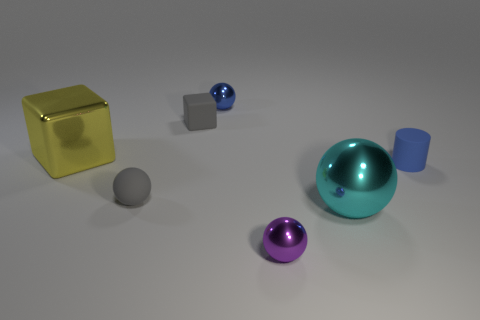Does the blue metallic thing have the same shape as the small purple object?
Offer a very short reply. Yes. How many matte objects are yellow blocks or tiny cyan cubes?
Keep it short and to the point. 0. What is the material of the thing that is the same color as the tiny cylinder?
Keep it short and to the point. Metal. Do the blue shiny thing and the yellow block have the same size?
Provide a short and direct response. No. How many objects are yellow shiny cubes or metal spheres that are on the left side of the small purple sphere?
Your answer should be very brief. 2. There is another object that is the same size as the cyan thing; what is its material?
Offer a very short reply. Metal. What is the small sphere that is both in front of the yellow cube and right of the matte sphere made of?
Provide a succinct answer. Metal. Are there any large objects that are in front of the shiny sphere on the right side of the purple shiny sphere?
Offer a very short reply. No. There is a thing that is to the left of the blue shiny thing and behind the big yellow shiny cube; what is its size?
Provide a short and direct response. Small. What number of purple things are either tiny objects or matte spheres?
Provide a short and direct response. 1. 